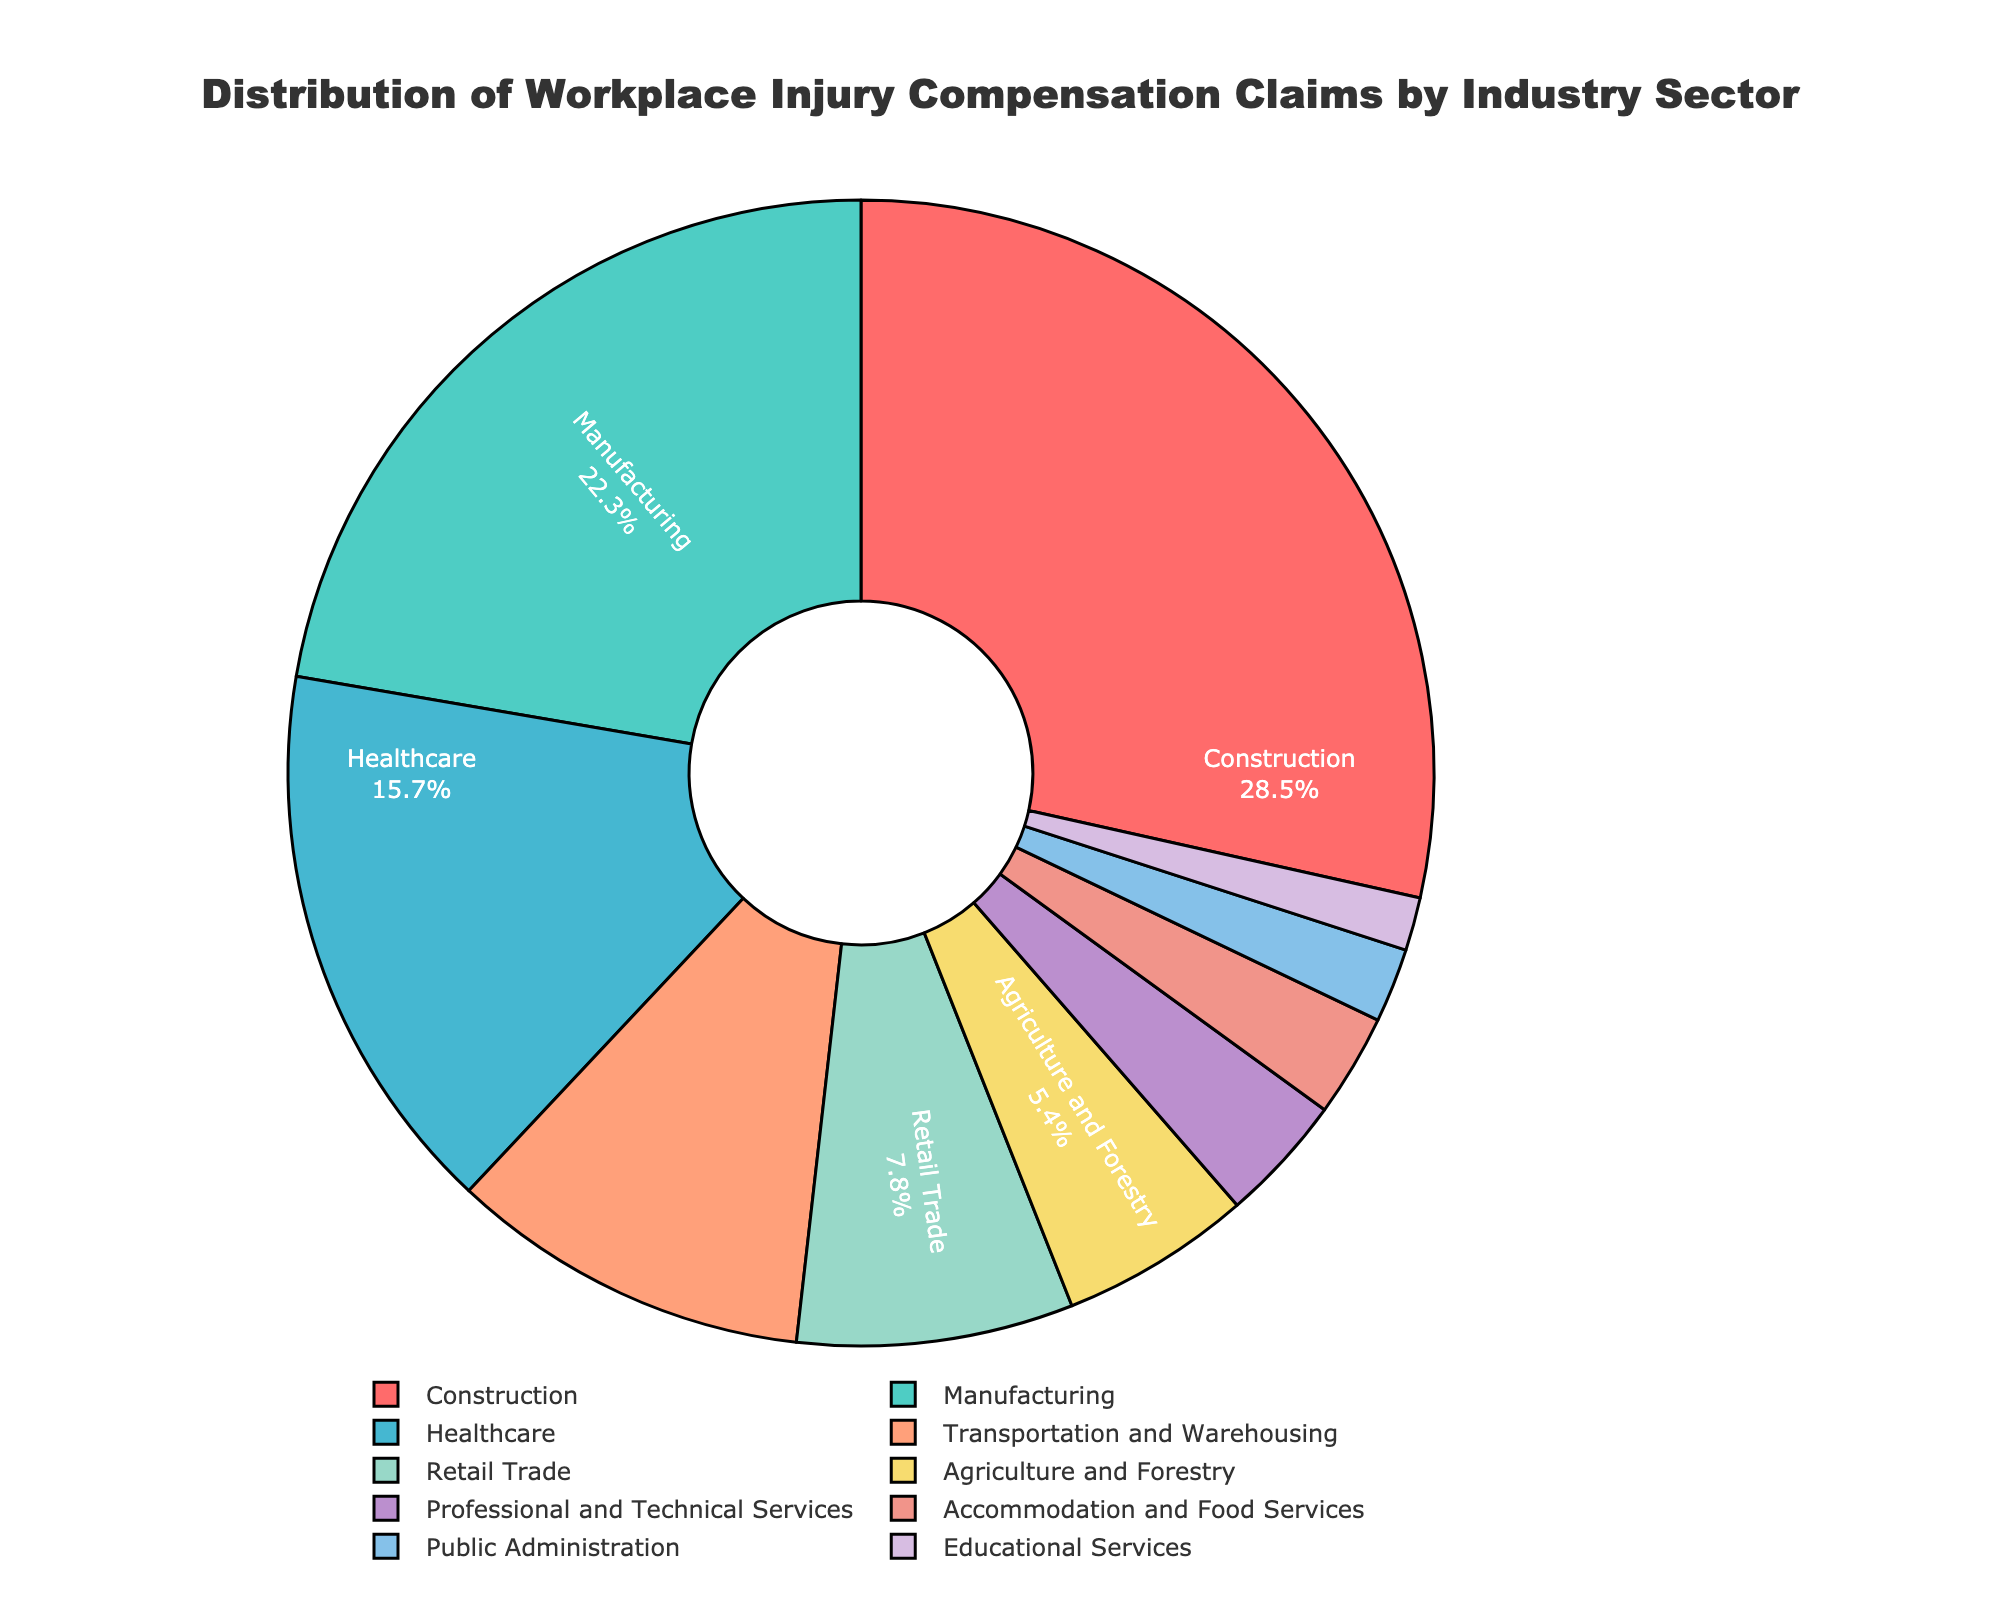Which industry sector has the highest percentage of workplace injury compensation claims? Look at the pie chart and identify the sector with the largest slice. Construction has the highest percentage indicated by the largest portion of the chart.
Answer: Construction What is the total percentage of claims for the Construction and Manufacturing sectors combined? Add the percentages of the Construction (28.5%) and Manufacturing (22.3%) sectors. 28.5 + 22.3 is 50.8.
Answer: 50.8% Which industry sectors account for less than 5% of the total claims? Identify the sectors whose slices are visually smaller and check their percentages. Professional and Technical Services (3.6%), Accommodation and Food Services (2.9%), Public Administration (2.1%), and Educational Services (1.5%) each have less than 5%.
Answer: Professional and Technical Services, Accommodation and Food Services, Public Administration, Educational Services How does the percentage of claims in Healthcare compare to that in Transportation and Warehousing? Compare the two given percentages. Healthcare is 15.7% and Transportation and Warehousing is 10.2%. Healthcare has a higher percentage.
Answer: Healthcare has more claims Which industry sector has the smallest percentage of workplace injury compensation claims? Look at the pie chart and identify the sector with the smallest slice. Educational Services has the smallest percentage indicated by the smallest portion of the chart.
Answer: Educational Services How much greater is the percentage of claims in Construction compared to Retail Trade? Subtract the percentage of Retail Trade (7.8%) from that of Construction (28.5%). 28.5 - 7.8 is 20.7.
Answer: 20.7% What percentage of the claims are from the sectors with higher than 10% claims? Add the percentages of Construction (28.5%), Manufacturing (22.3%), and Healthcare (15.7%) sectors. Total is 28.5 + 22.3 + 15.7 = 66.5.
Answer: 66.5% Arrange the sectors in decreasing order of their claims percentage. List the sectors and arrange them based on their percentages from highest to lowest: Construction (28.5%), Manufacturing (22.3%), Healthcare (15.7%), Transportation and Warehousing (10.2%), Retail Trade (7.8%), Agriculture and Forestry (5.4%), Professional and Technical Services (3.6%), Accommodation and Food Services (2.9%), Public Administration (2.1%), Educational Services (1.5%).
Answer: Construction, Manufacturing, Healthcare, Transportation and Warehousing, Retail Trade, Agriculture and Forestry, Professional and Technical Services, Accommodation and Food Services, Public Administration, Educational Services What is the combined percentage of claims in Agriculture and Forestry and Professional and Technical Services? Add the percentages of Agriculture and Forestry (5.4%) and Professional and Technical Services (3.6%). 5.4 + 3.6 is 9.0.
Answer: 9.0% Which sectors together form about a third of total claims? Sum percentages of sectors: Agriculture and Forestry (5.4%), Professional and Technical Services (3.6%), Accommodation and Food Services (2.9%), Public Administration (2.1%), Educational Services (1.5%) ≈ 15.5%; this is less than half, conclude: Construction (28.5%) ≈ 30%.
Answer: Construction 